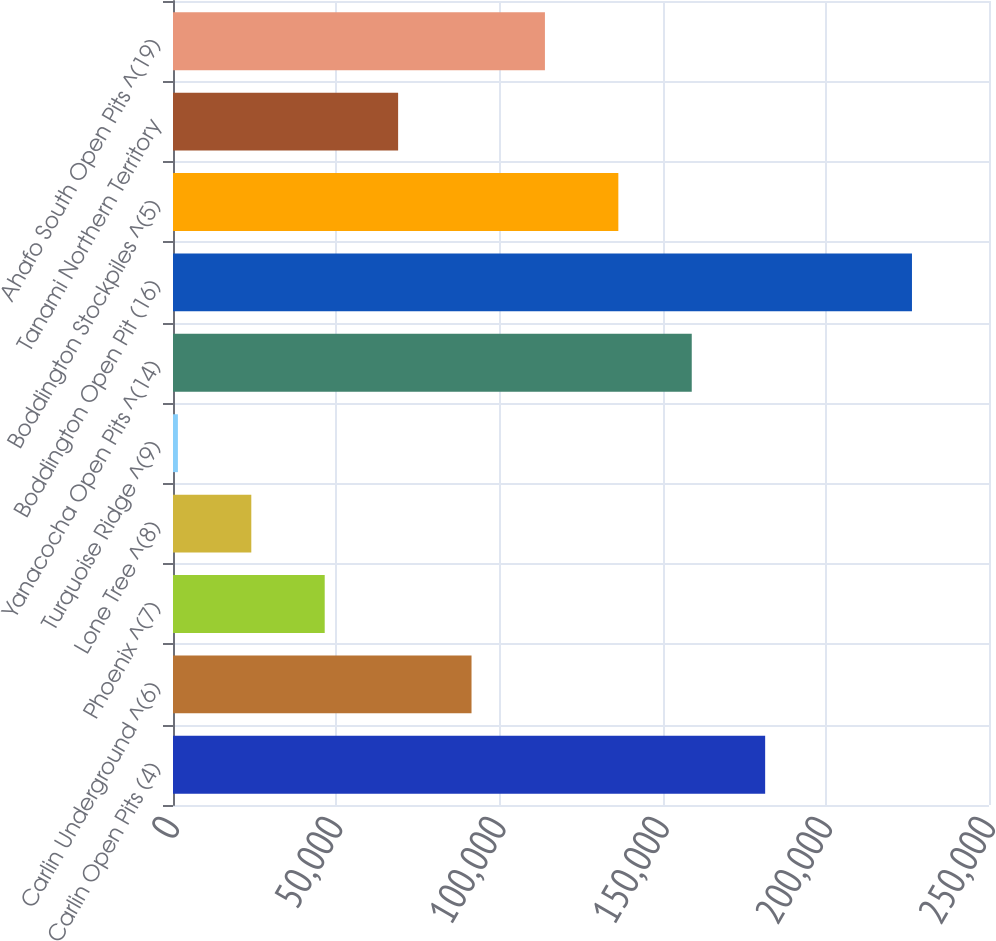Convert chart to OTSL. <chart><loc_0><loc_0><loc_500><loc_500><bar_chart><fcel>Carlin Open Pits (4)<fcel>Carlin Underground ^(6)<fcel>Phoenix ^(7)<fcel>Lone Tree ^(8)<fcel>Turquoise Ridge ^(9)<fcel>Yanacocha Open Pits ^(14)<fcel>Boddington Open Pit (16)<fcel>Boddington Stockpiles ^(5)<fcel>Tanami Northern Territory<fcel>Ahafo South Open Pits ^(19)<nl><fcel>181420<fcel>91460<fcel>46480<fcel>23990<fcel>1500<fcel>158930<fcel>226400<fcel>136440<fcel>68970<fcel>113950<nl></chart> 